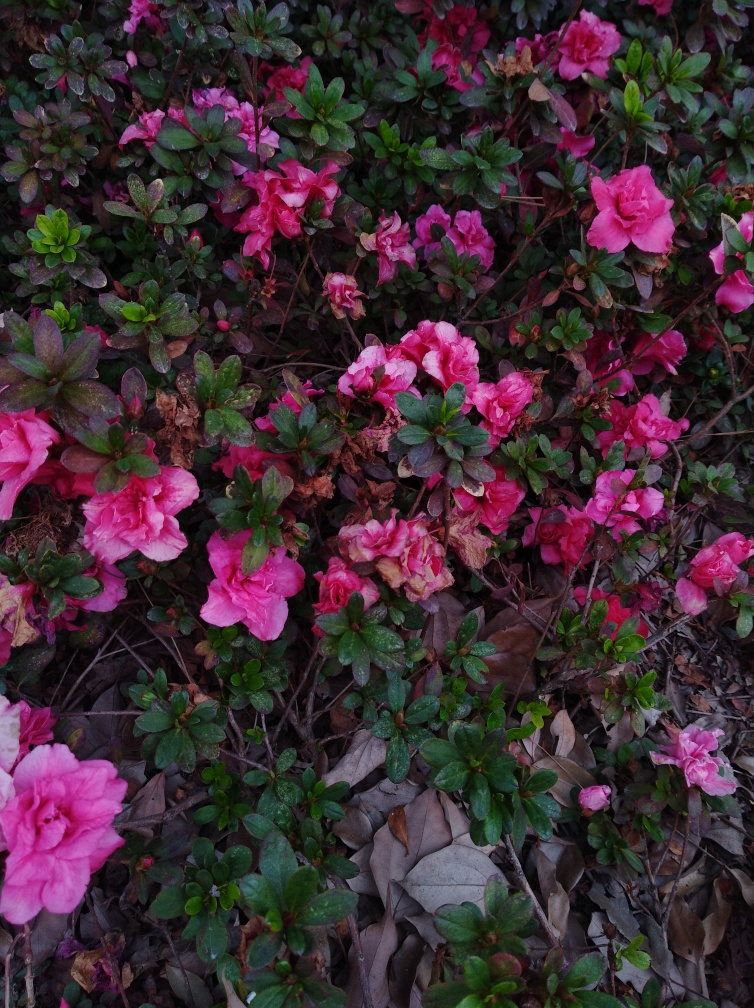Could the colors of these flowers have any specific significance? Indeed, flower colors often have traditional meanings. Pink azaleas can symbolize femininity, playfulness, and joy, while the presence of wilted or brown flowers could remind us of the impermanence of beauty and the importance of care and attention. Are there any particular occasions when azaleas are gifted? Azaleas are commonly gifted as a symbol of affection or appreciation. They are sometimes given on Mother's Day, weddings, or as housewarming gifts due to their beauty and the positive sentiments they convey. 